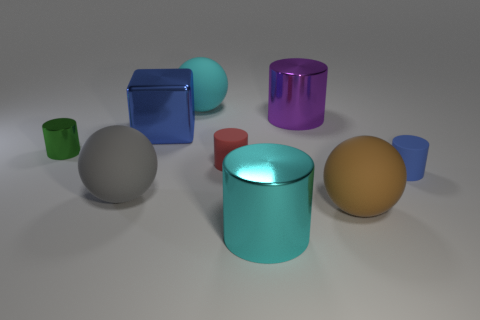How many yellow objects are tiny rubber cylinders or metal cylinders? 0 